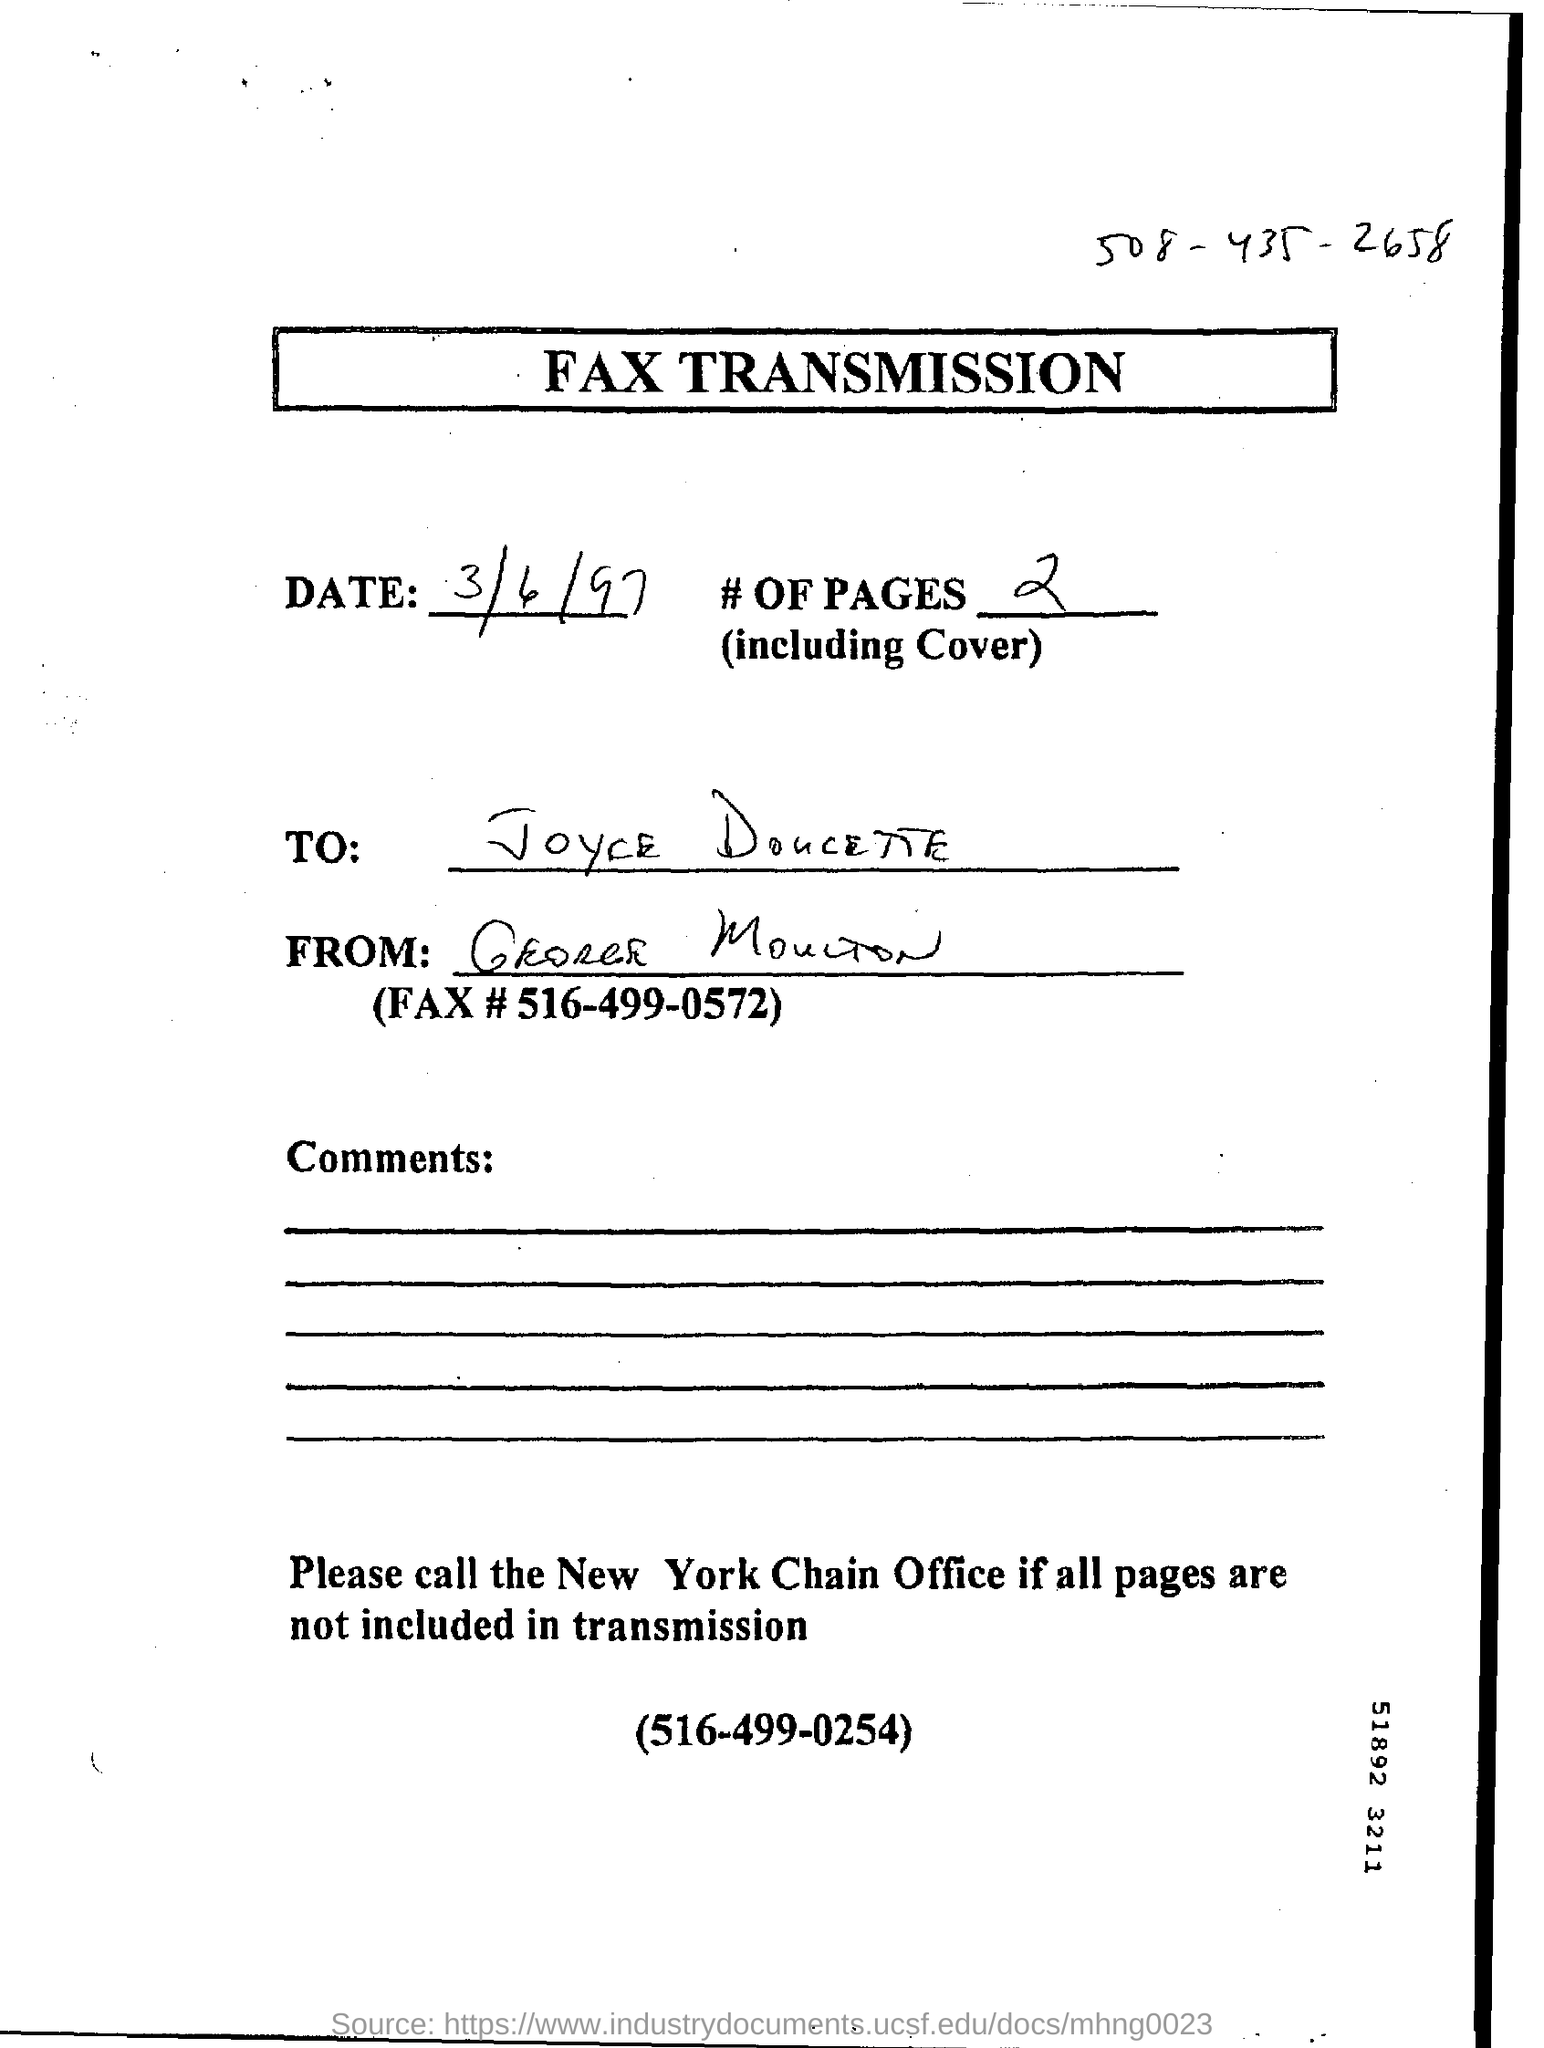Draw attention to some important aspects in this diagram. The date of the document is March 6th, 1997. The headline of this document is 'FAX TRANSMISSION.' The number of pages is two... 